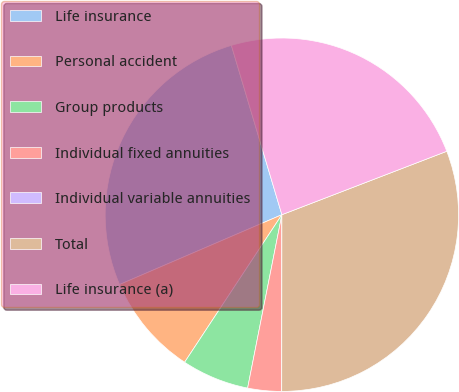Convert chart to OTSL. <chart><loc_0><loc_0><loc_500><loc_500><pie_chart><fcel>Life insurance<fcel>Personal accident<fcel>Group products<fcel>Individual fixed annuities<fcel>Individual variable annuities<fcel>Total<fcel>Life insurance (a)<nl><fcel>26.85%<fcel>9.26%<fcel>6.17%<fcel>3.09%<fcel>0.0%<fcel>30.86%<fcel>23.77%<nl></chart> 